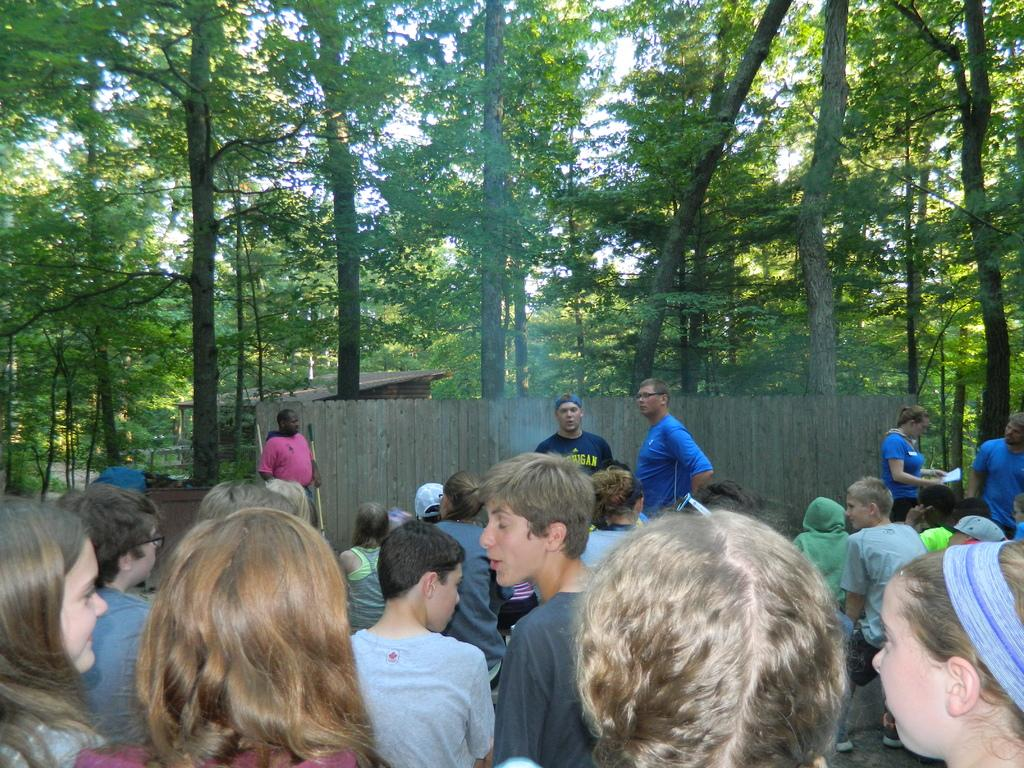How many people are in the image? There are people in the image, but the exact number is not specified. What are some of the people doing in the image? Some people are holding objects in their hands. What can be seen in the background of the image? There are sheds, trees, and other unspecified objects in the background of the image. What type of knowledge is the carpenter demonstrating in the image? There is no carpenter present in the image, and therefore no knowledge can be demonstrated. How does the person in the image control the unspecified objects in the background? There is no indication in the image that anyone is controlling any objects, unspecified or otherwise. 